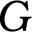<formula> <loc_0><loc_0><loc_500><loc_500>G</formula> 